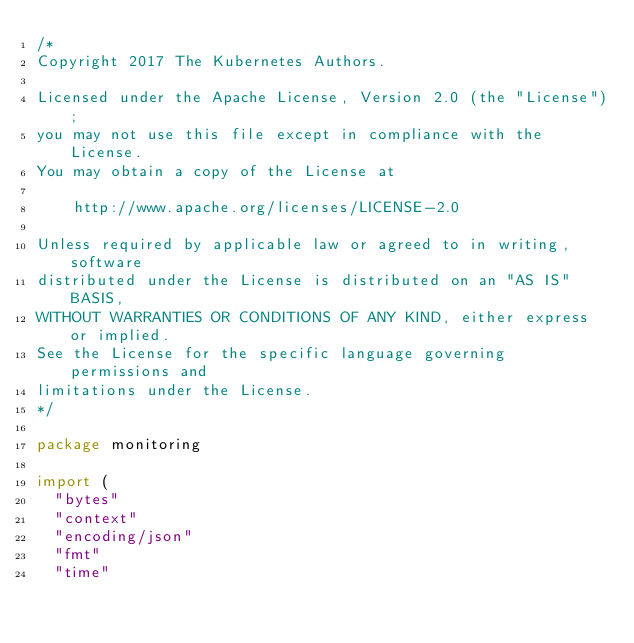<code> <loc_0><loc_0><loc_500><loc_500><_Go_>/*
Copyright 2017 The Kubernetes Authors.

Licensed under the Apache License, Version 2.0 (the "License");
you may not use this file except in compliance with the License.
You may obtain a copy of the License at

    http://www.apache.org/licenses/LICENSE-2.0

Unless required by applicable law or agreed to in writing, software
distributed under the License is distributed on an "AS IS" BASIS,
WITHOUT WARRANTIES OR CONDITIONS OF ANY KIND, either express or implied.
See the License for the specific language governing permissions and
limitations under the License.
*/

package monitoring

import (
	"bytes"
	"context"
	"encoding/json"
	"fmt"
	"time"
</code> 